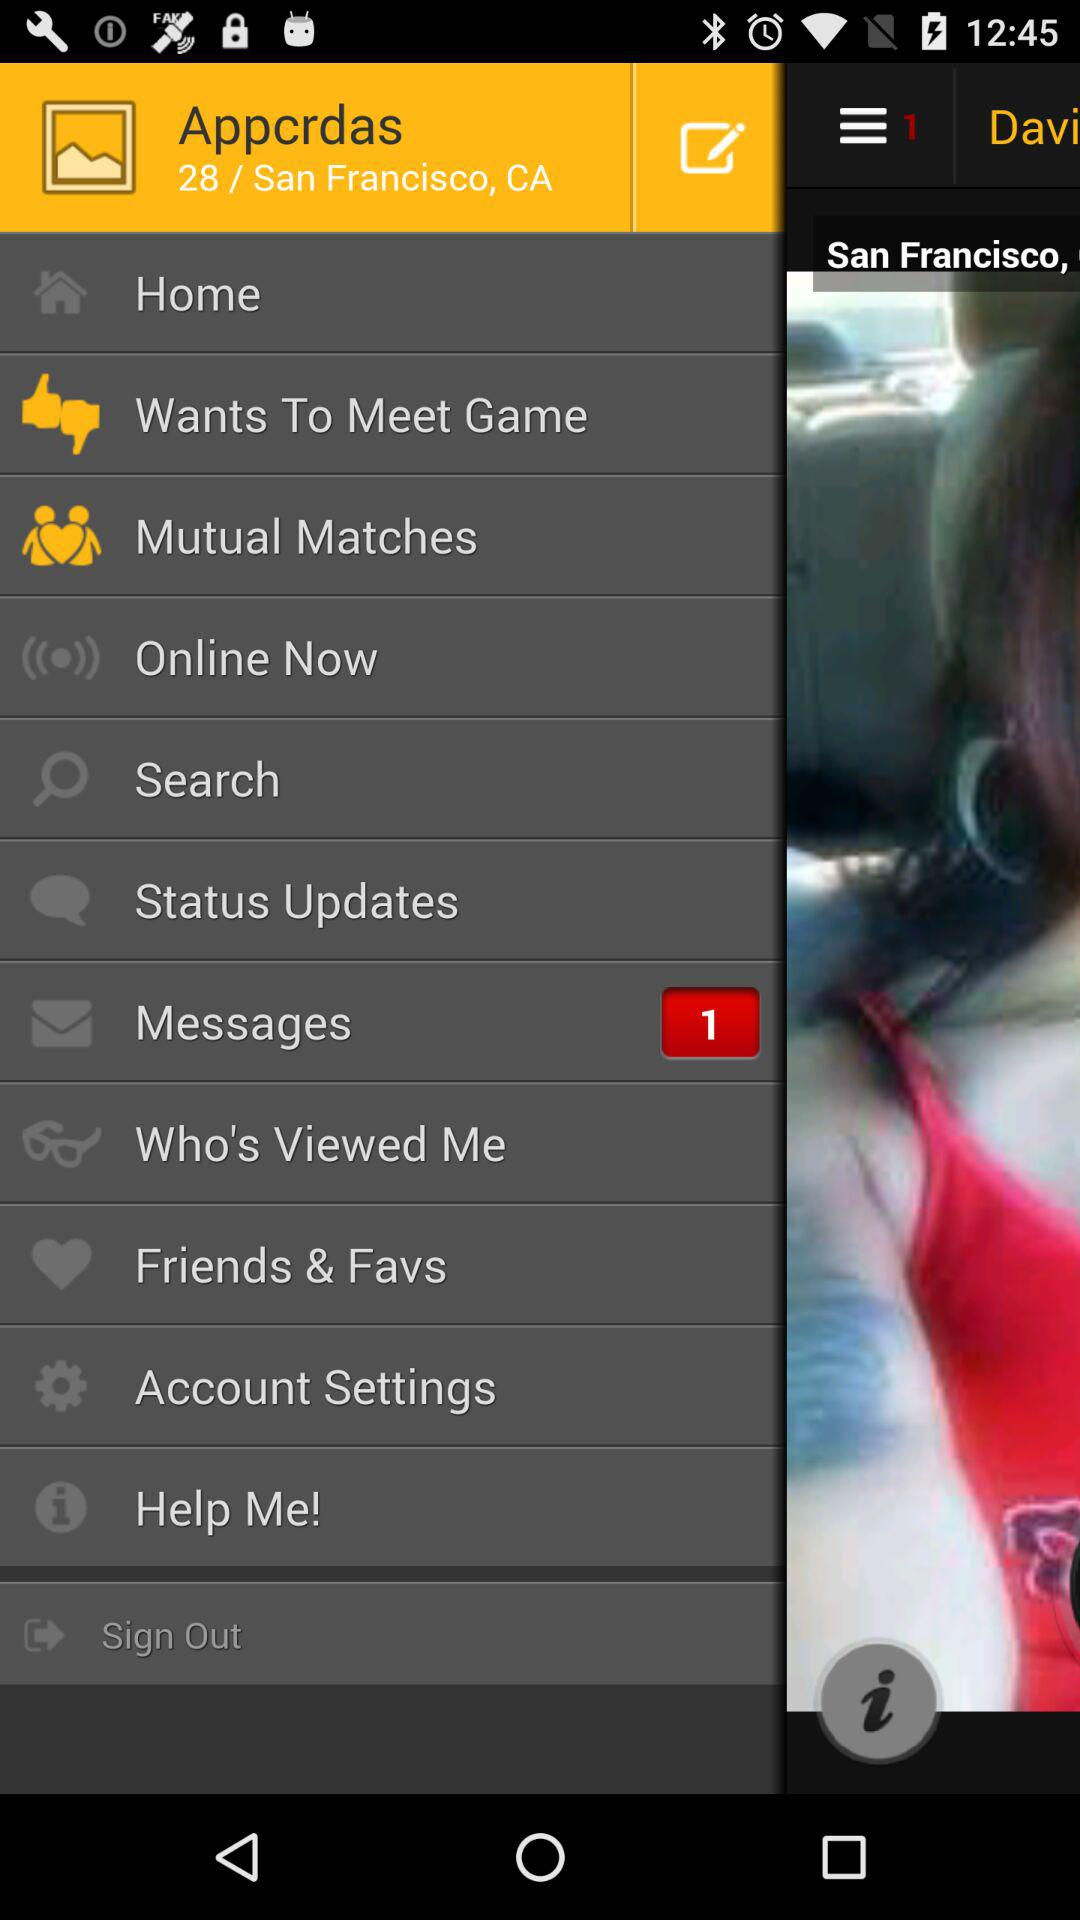What is the username? The username is "Appcrdas". 